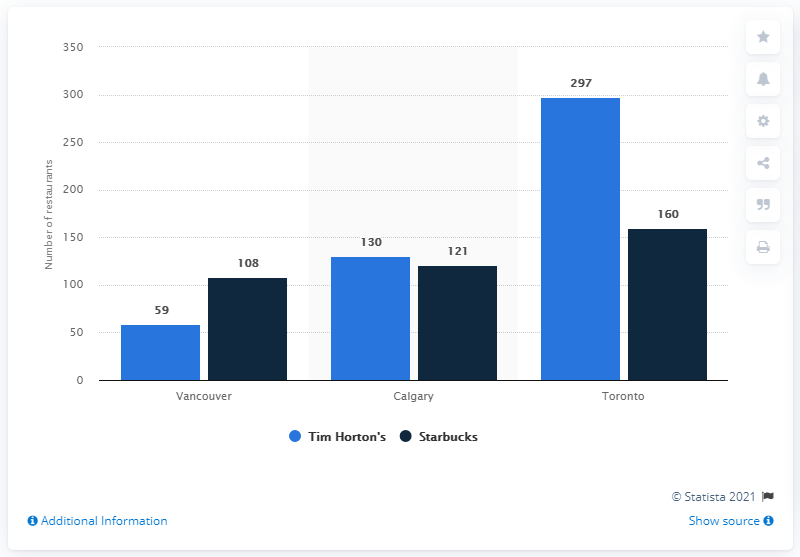Mention a couple of crucial points in this snapshot. There were 59 Tim Hortons stores in Vancouver as of January 2015. There were 108 Starbucks coffee houses in Vancouver in January 2015. 